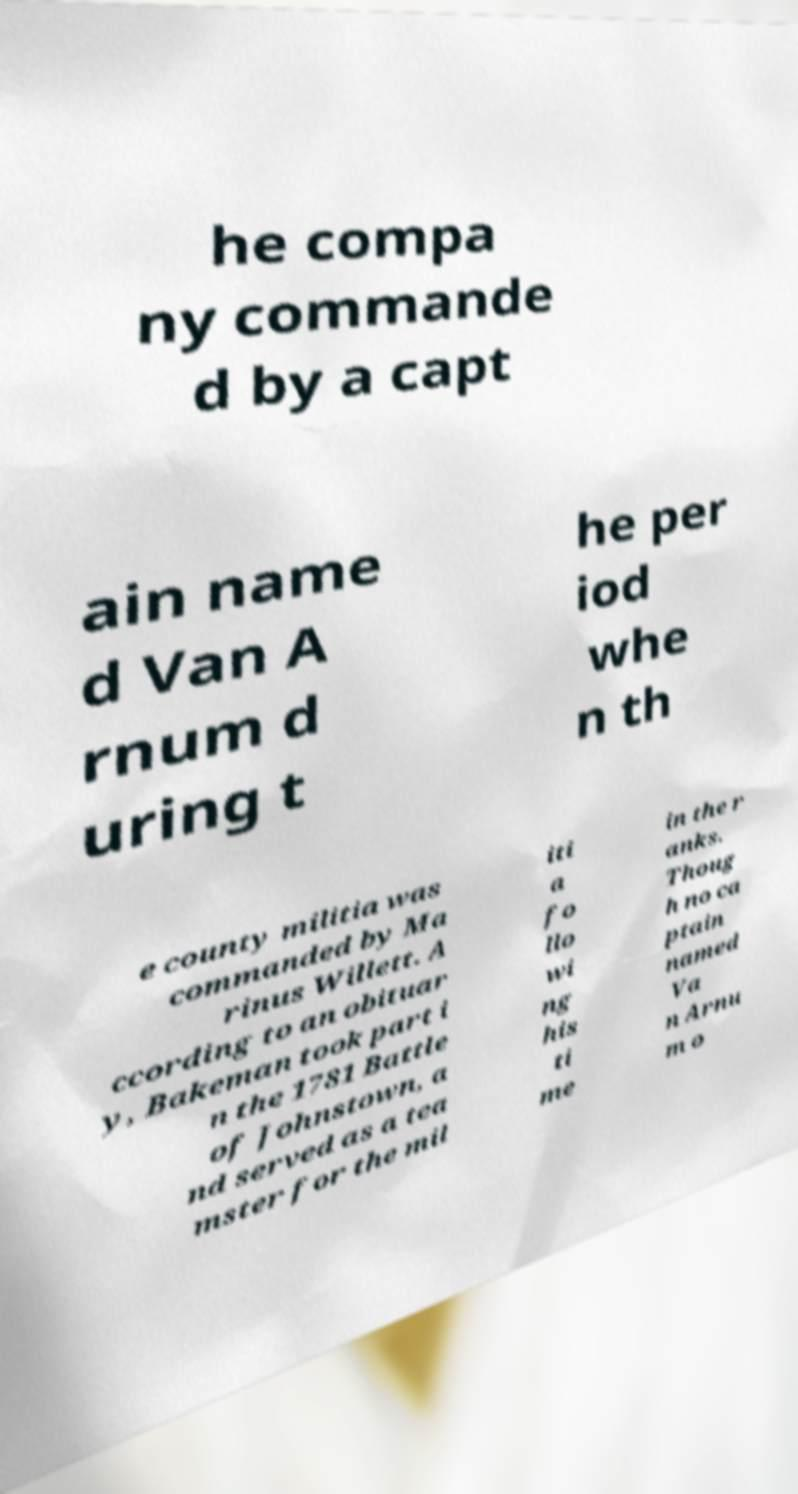For documentation purposes, I need the text within this image transcribed. Could you provide that? he compa ny commande d by a capt ain name d Van A rnum d uring t he per iod whe n th e county militia was commanded by Ma rinus Willett. A ccording to an obituar y, Bakeman took part i n the 1781 Battle of Johnstown, a nd served as a tea mster for the mil iti a fo llo wi ng his ti me in the r anks. Thoug h no ca ptain named Va n Arnu m o 